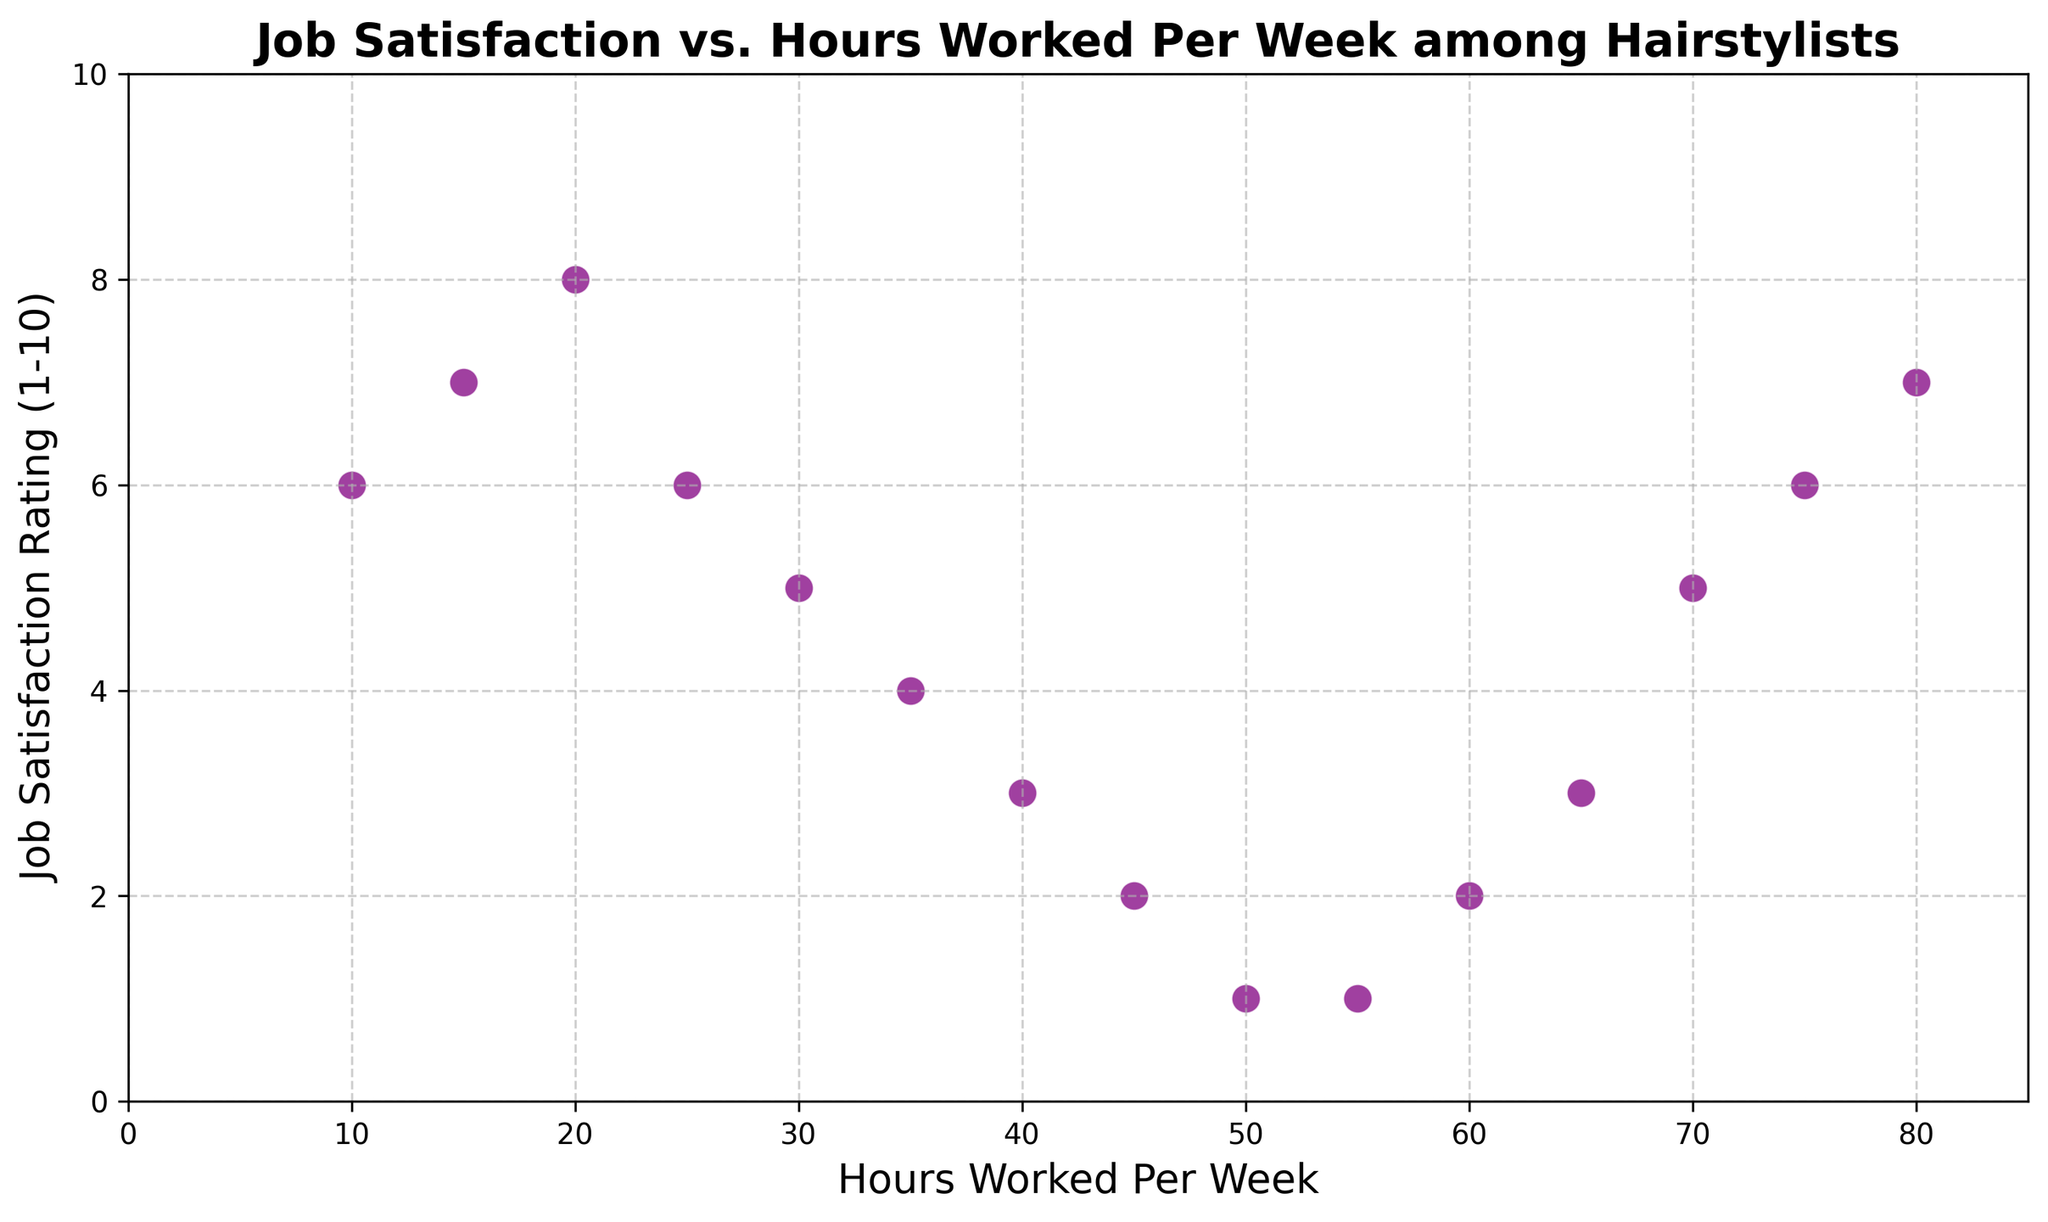What is the general trend shown in the scatter plot? By looking at the overall pattern of the points in the scatter plot, we can see that job satisfaction tends to decrease as the number of hours worked per week increases.
Answer: Job satisfaction decreases with more hours worked Which data point represents the highest hours worked and what is the corresponding job satisfaction rating? By identifying the data point furthest to the right of the x-axis, this represents 80 hours worked per week. The corresponding job satisfaction rating on the y-axis for this point is 7.
Answer: 80 hours, 7 Is there any point where job satisfaction rating is at its lowest and what are the hours worked for that point? By locating the points with the lowest job satisfaction rating on the y-axis, we can see there are two points with a rating of 1, corresponding to 50 and 55 hours worked per week.
Answer: 50 and 55 hours What is the difference in job satisfaction rating between working 20 hours and 50 hours per week? The job satisfaction rating for 20 hours is 8, and for 50 hours it is 1. By subtracting 1 from 8, the difference is 7.
Answer: 7 Which has a higher job satisfaction rating: working 10 hours per week or 35 hours per week? By locating the data points for 10 hours and 35 hours on the x-axis and comparing their heights on the y-axis, we see that 10 hours has a rating of 6 while 35 hours has a rating of 4. Therefore, 10 hours per week has a higher job satisfaction rating.
Answer: 10 hours per week How many hours worked per week correspond to a job satisfaction rating of 3? By locating the points on the y-axis corresponding to a job satisfaction rating of 3 and then checking their position on the x-axis, we find that 40 and 65 hours per week have a job satisfaction rating of 3.
Answer: 40 and 65 hours per week What is the average job satisfaction rating for hairstylists working 15, 60, and 75 hours per week? The job satisfaction ratings for 15, 60, and 75 hours are 7, 2, and 6 respectively. Adding these together gives 7 + 2 + 6 = 15. Dividing by the number of values, 3, results in an average of 15 / 3 = 5.
Answer: 5 What could be inferred about job satisfaction for hairstylists working exactly 25 hours per week? By locating the point on the scatter plot for 25 hours on the x-axis, we see that the corresponding job satisfaction rating on the y-axis is 6.
Answer: Job satisfaction rating of 6 